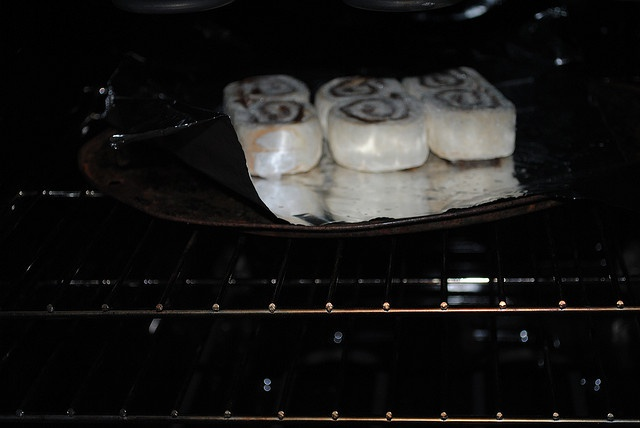Describe the objects in this image and their specific colors. I can see cake in black, darkgray, and gray tones, cake in black, darkgray, gray, and lightgray tones, and cake in black, darkgray, and gray tones in this image. 